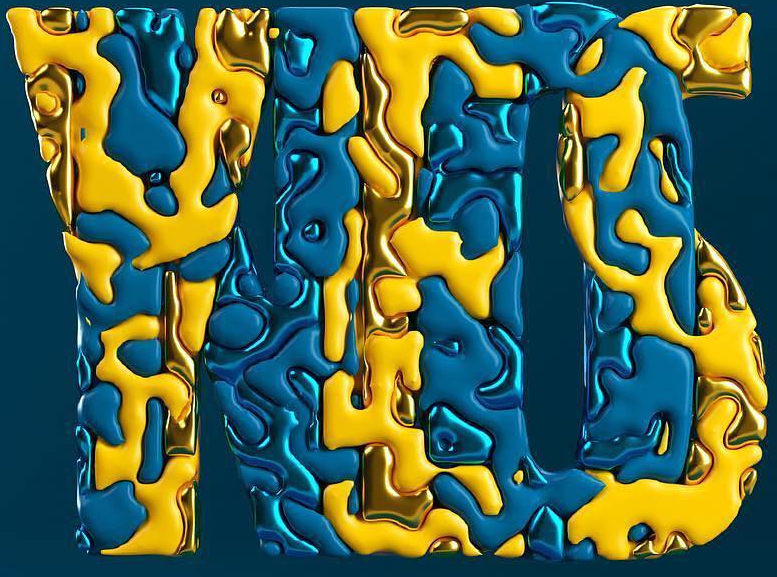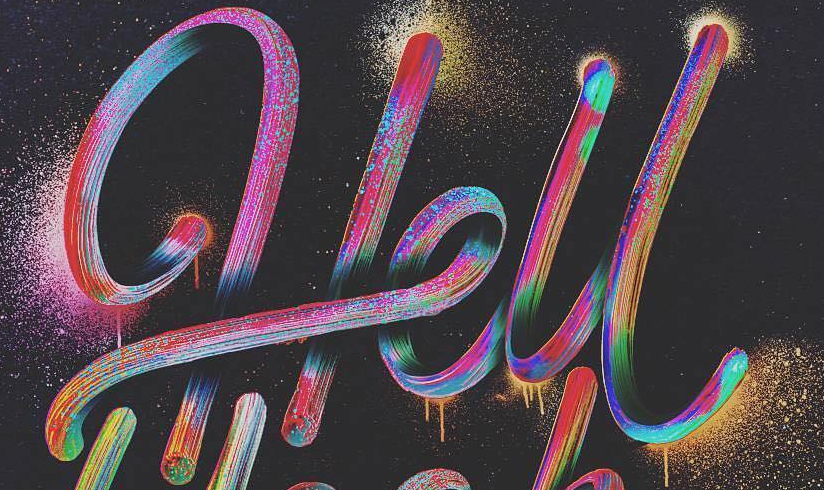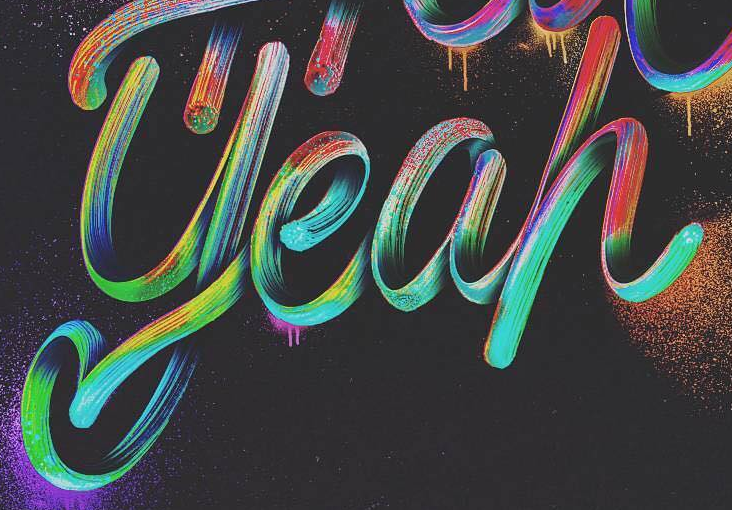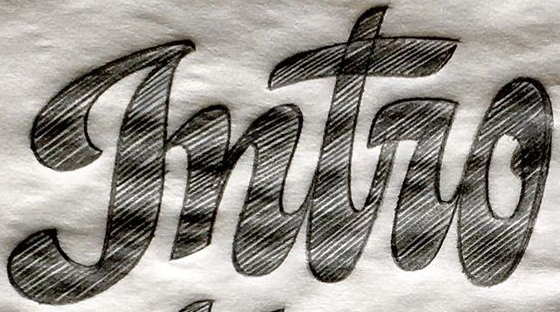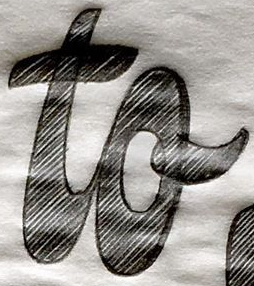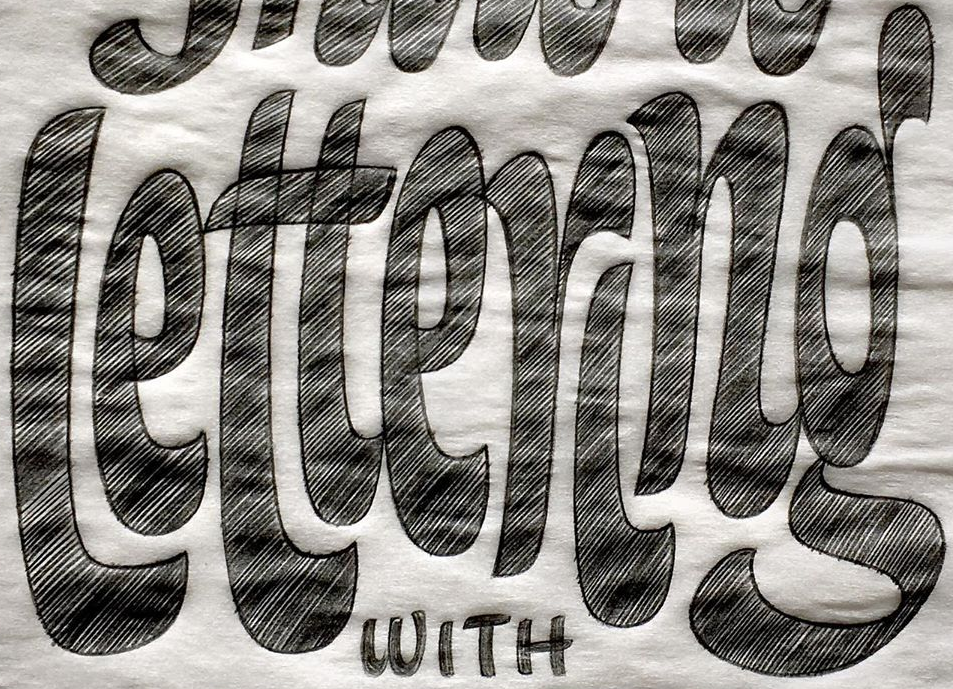Transcribe the words shown in these images in order, separated by a semicolon. YES; Hell; yeah; gntro; to; lettering 